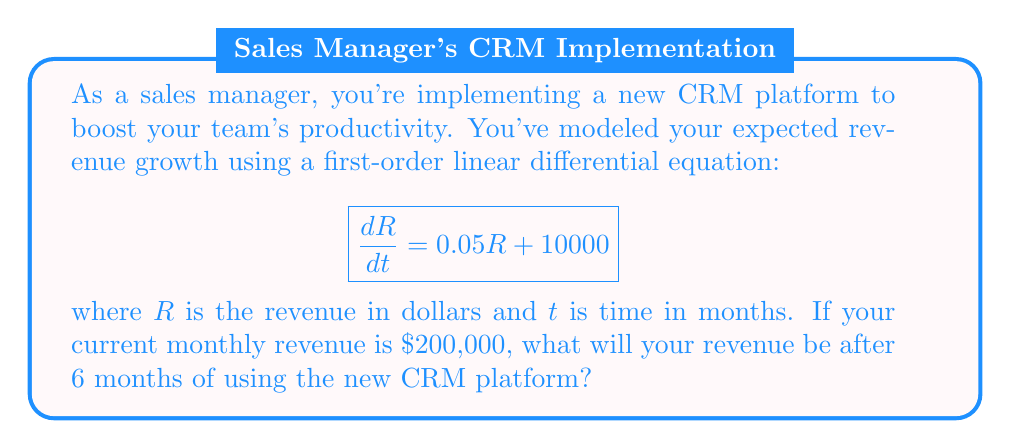What is the answer to this math problem? Let's solve this step-by-step:

1) The given differential equation is:
   $$\frac{dR}{dt} = 0.05R + 10000$$

2) This is a first-order linear differential equation of the form:
   $$\frac{dy}{dx} + P(x)y = Q(x)$$
   where $P(x) = -0.05$ and $Q(x) = 10000$

3) The general solution for this type of equation is:
   $$R(t) = e^{-\int P(t)dt} \left( \int Q(t)e^{\int P(t)dt}dt + C \right)$$

4) Solving the integrals:
   $$R(t) = e^{0.05t} \left( \int 10000e^{-0.05t}dt + C \right)$$
   $$R(t) = e^{0.05t} \left( -200000e^{-0.05t} + C \right)$$
   $$R(t) = -200000 + Ce^{0.05t}$$

5) Using the initial condition $R(0) = 200000$:
   $$200000 = -200000 + C$$
   $$C = 400000$$

6) Therefore, the particular solution is:
   $$R(t) = -200000 + 400000e^{0.05t}$$

7) To find the revenue after 6 months, we calculate $R(6)$:
   $$R(6) = -200000 + 400000e^{0.05(6)}$$
   $$R(6) = -200000 + 400000e^{0.3}$$
   $$R(6) = -200000 + 400000(1.34986)$$
   $$R(6) = 339944$$

Therefore, after 6 months, the revenue will be approximately $339,944.
Answer: $339,944 